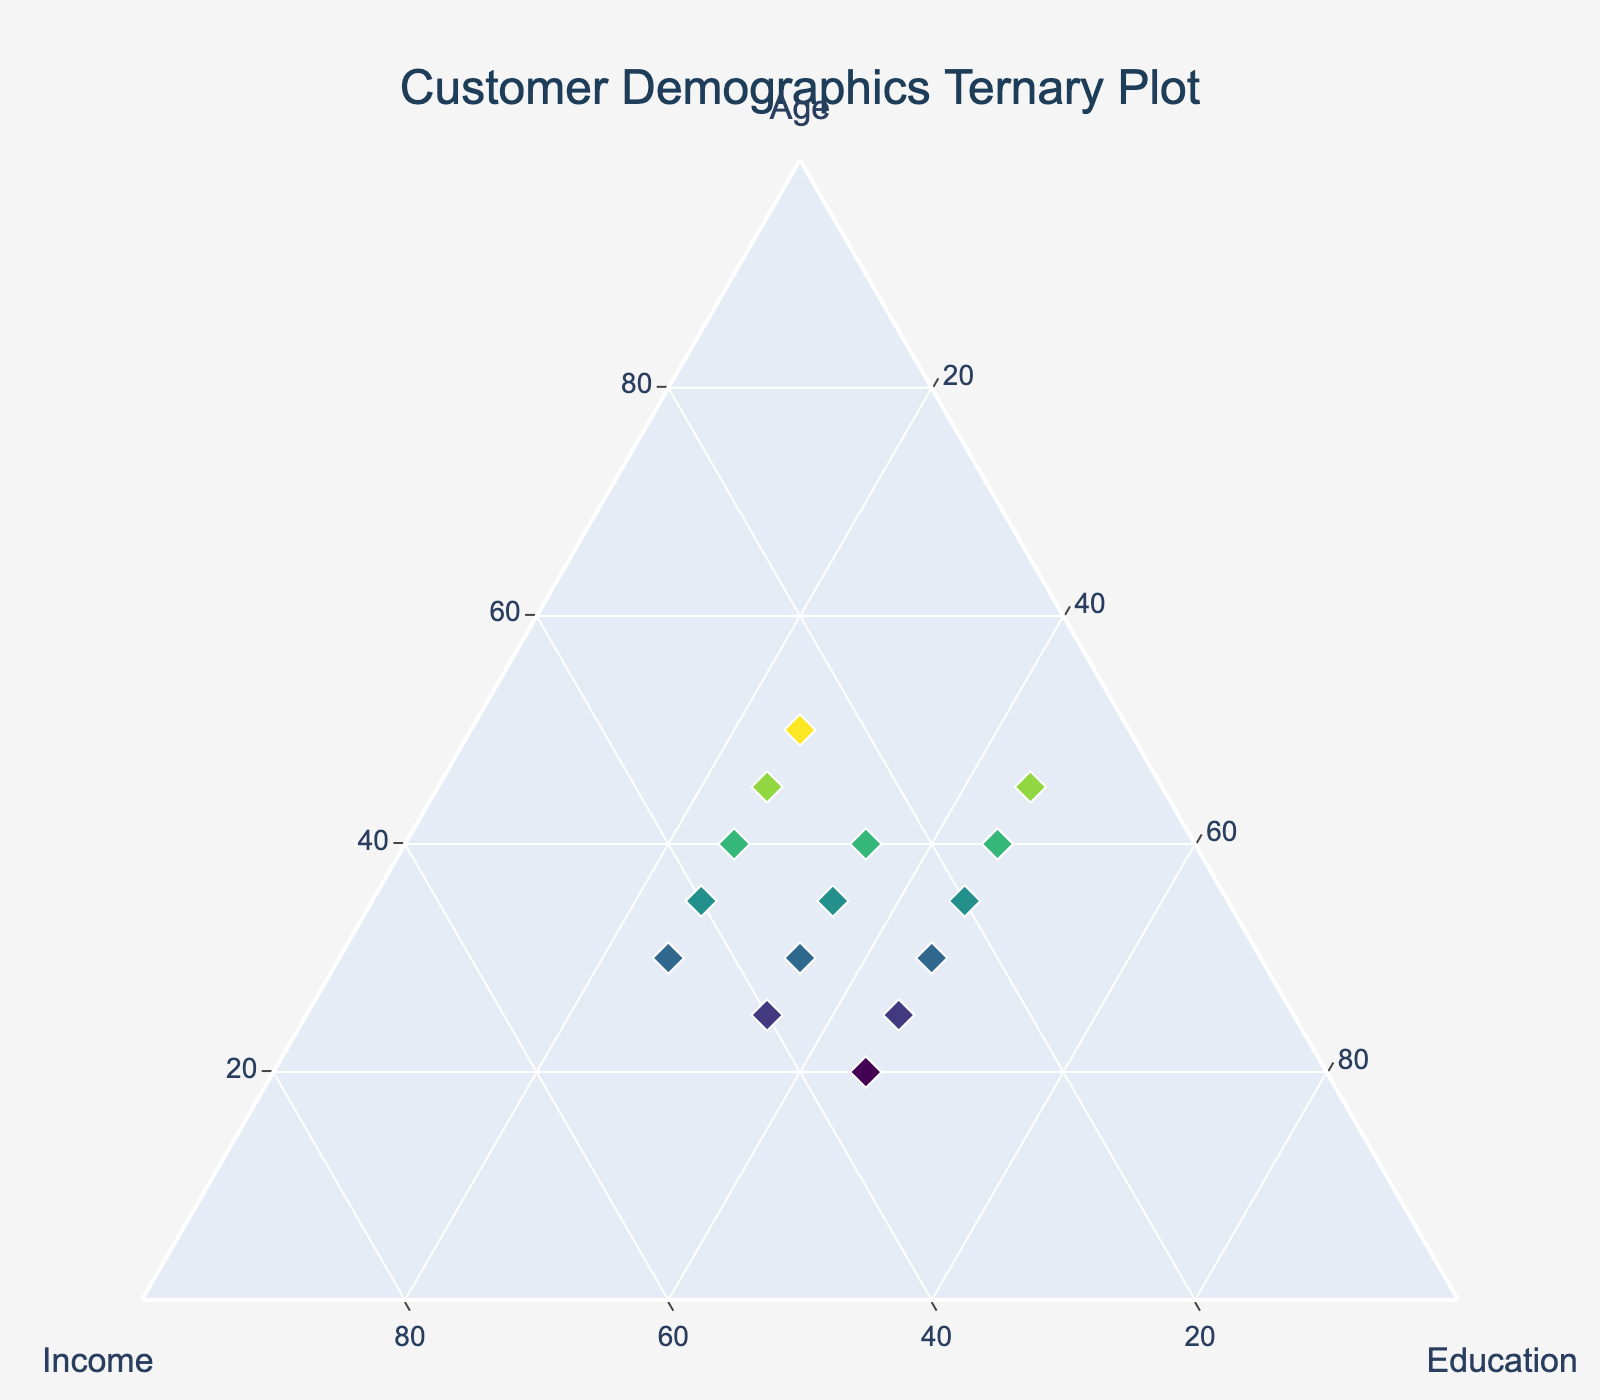What is the title of the plot? The title of the plot is displayed at the top and is typically larger in font size compared to other text elements. By looking at the figure, you can see this easily.
Answer: Customer Demographics Ternary Plot How many distinct data points are represented in the figure? Each data point is depicted as a diamond marker in the ternary plot. You can count these markers to find the total number of data points.
Answer: 15 Which axis represents 'Education'? In a ternary plot, each vertex represents one of the three variables. By looking at the axis titles in the plot, you can identify which variable corresponds to which axis.
Answer: The axis labeled 'Education' What is the sum of the values along each axis of the plot? Ternary plots typically represent data where the sum of the three variables equals a specific constant, often 100. This can usually be seen in the plot settings or description. Here, it is explicitly mentioned in the settings with 'sum': 100.
Answer: 100 Which data point has the highest education level? By identifying the highest value along the 'Education' axis, you can determine which data point represents the customers with the highest level of education.
Answer: Age: 45, Income: 10, Education: 45 Compare the ages of customers with the lowest income levels. Identify the data points with the lowest values along the 'Income' axis and compare their 'Age' values to determine this.
Answer: Ages are 40 and 45 What are the age and income values for the customers with 35% education level? Data points corresponding to 35% education can be found by looking at the 'Education' axis. Then, check their respective 'Age' and 'Income' values.
Answer: (Age: 25, Income: 40), (Age: 30, Income: 35), (Age: 35, Income: 30), (Age: 40, Income: 25) What is the average age of customers with 25% education level? Identify the data points with 25% education, sum their 'Age' values, and then divide by the number of such data points to find the average. Ages are 30, 35, 40, 45, 50. Sum = 200. Average = 200/5 = 40
Answer: 40 Which age group appears most frequently in the dataset? By observing the 'Age' values for each data point, verify which age occurs more frequently.
Answer: Age: 30 and Age: 35 (both occur 3 times) Is there a trend between age and education levels? By examining if higher education levels correlate with a specific pattern in age values, you can identify trends. For example, higher education levels might be associated with younger or older age groups.
Answer: Higher education tends to be associated with younger ages 